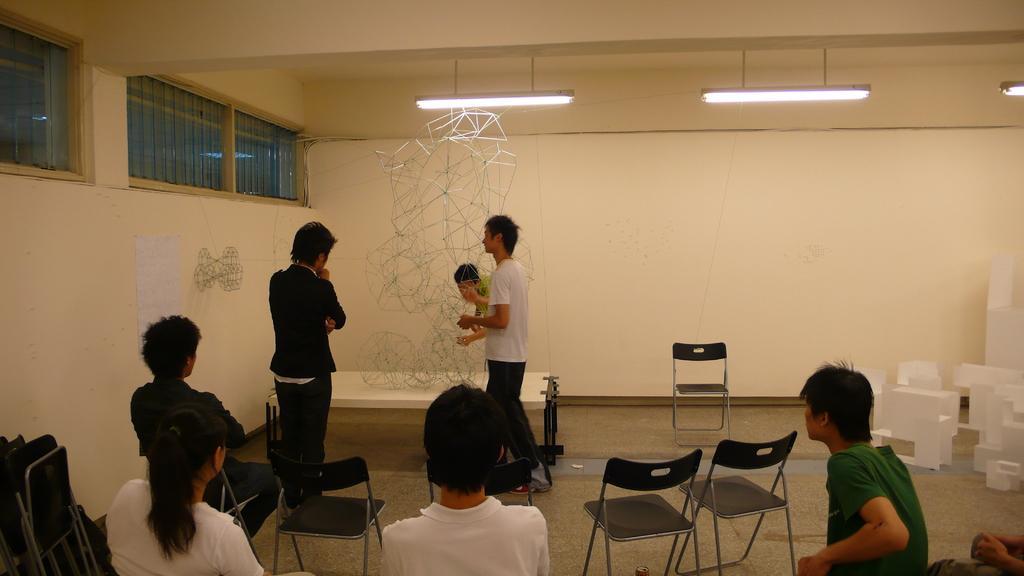Describe this image in one or two sentences. In this image I see 5 persons sitting on the chair and 3 persons standing over here. I can also see there are 3 lights on the ceiling and the wall and a paper on it. 